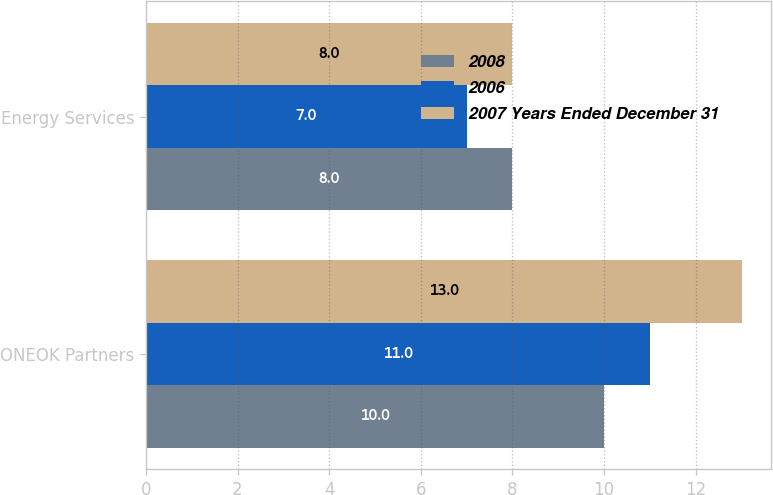Convert chart. <chart><loc_0><loc_0><loc_500><loc_500><stacked_bar_chart><ecel><fcel>ONEOK Partners<fcel>Energy Services<nl><fcel>2008<fcel>10<fcel>8<nl><fcel>2006<fcel>11<fcel>7<nl><fcel>2007 Years Ended December 31<fcel>13<fcel>8<nl></chart> 